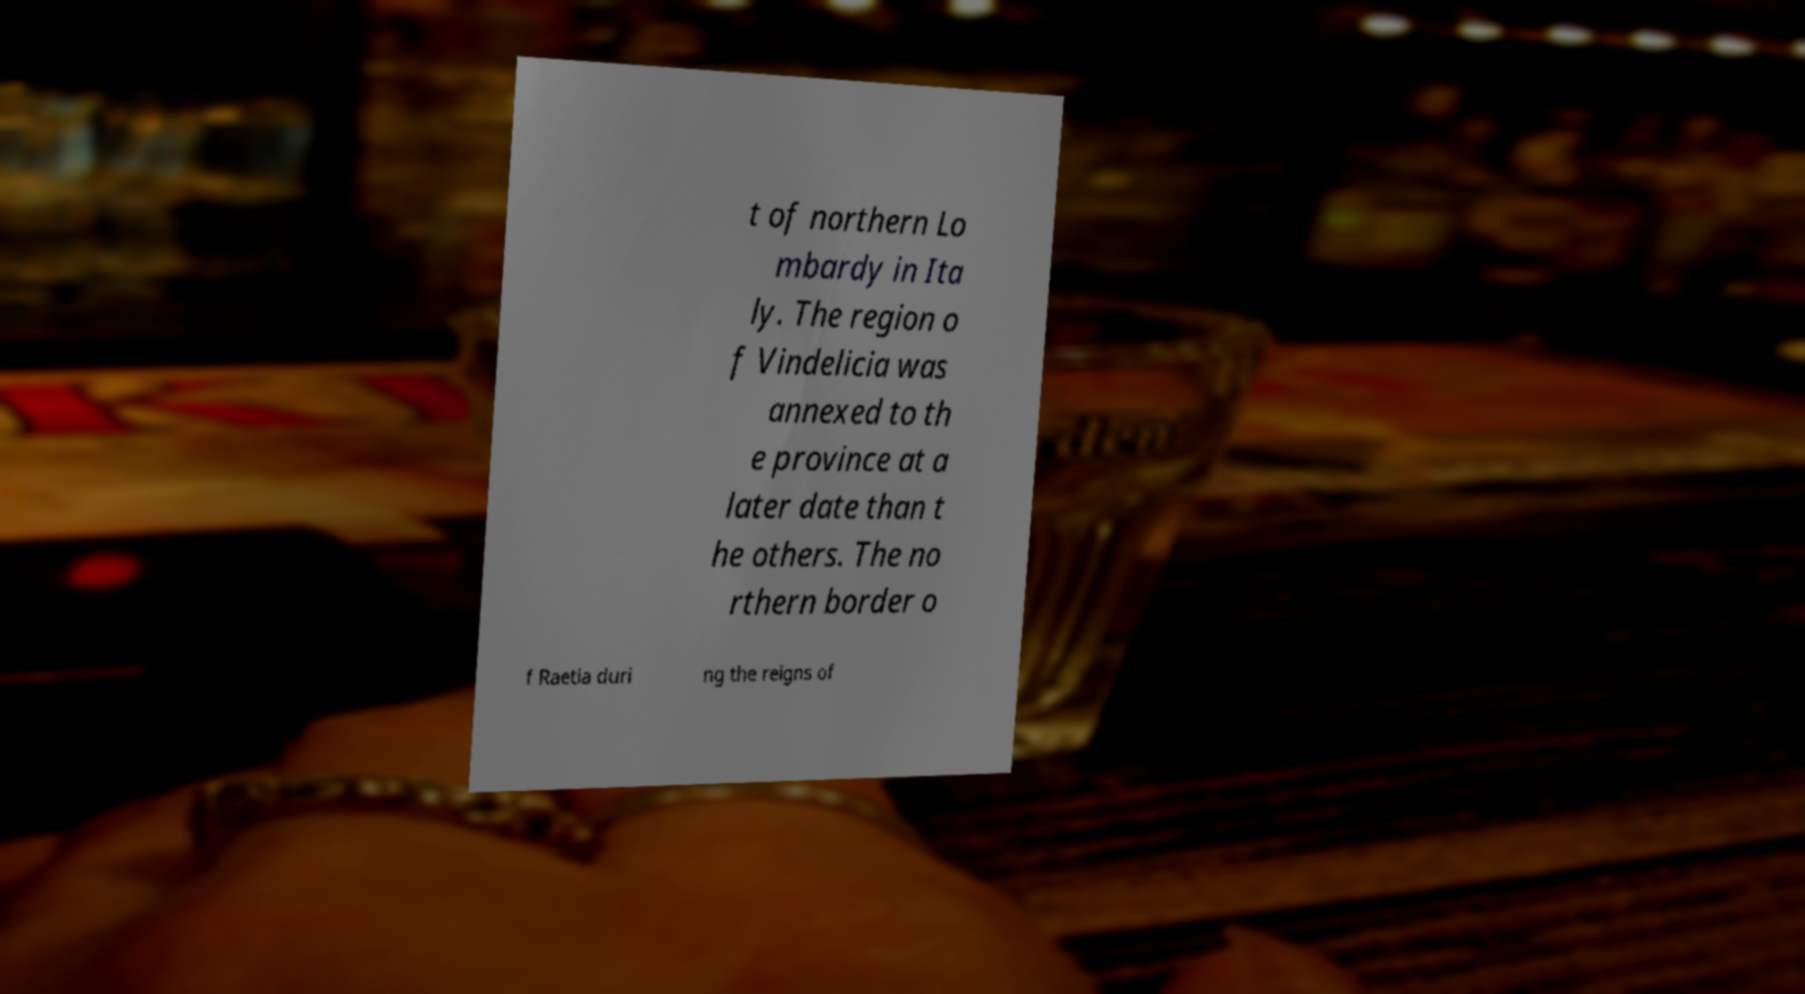There's text embedded in this image that I need extracted. Can you transcribe it verbatim? t of northern Lo mbardy in Ita ly. The region o f Vindelicia was annexed to th e province at a later date than t he others. The no rthern border o f Raetia duri ng the reigns of 